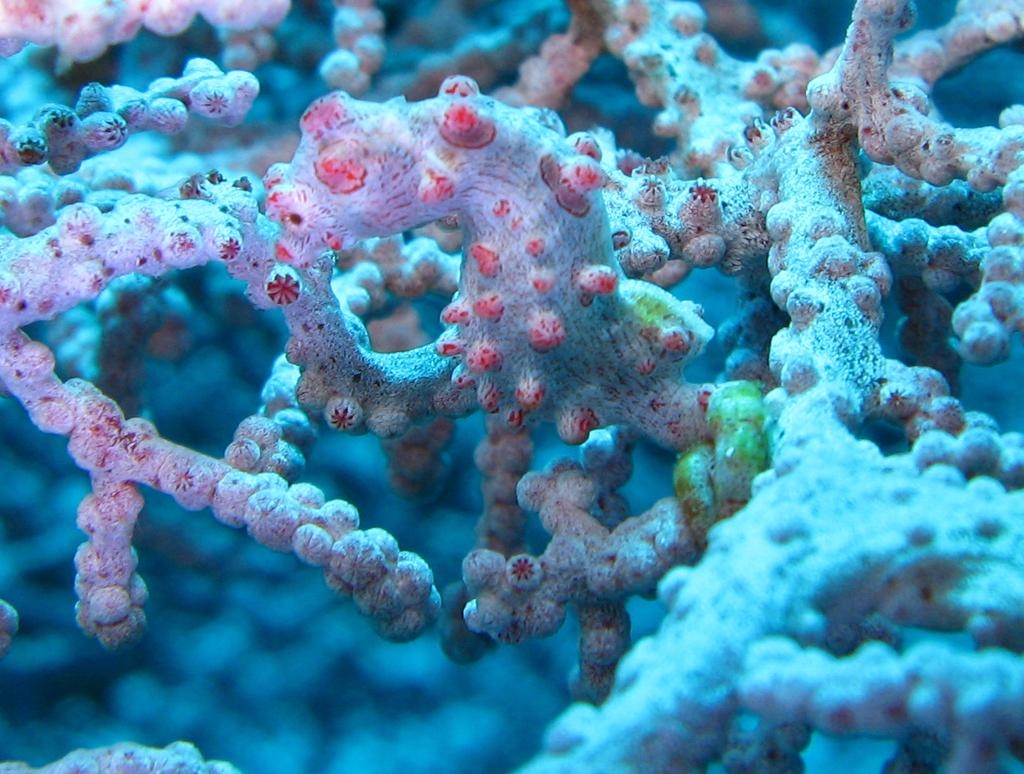What type of plants can be seen in the image? There are aquatic plants in the image. What type of treatment is being administered to the truck in the image? There is no truck present in the image, and therefore no treatment can be observed. 